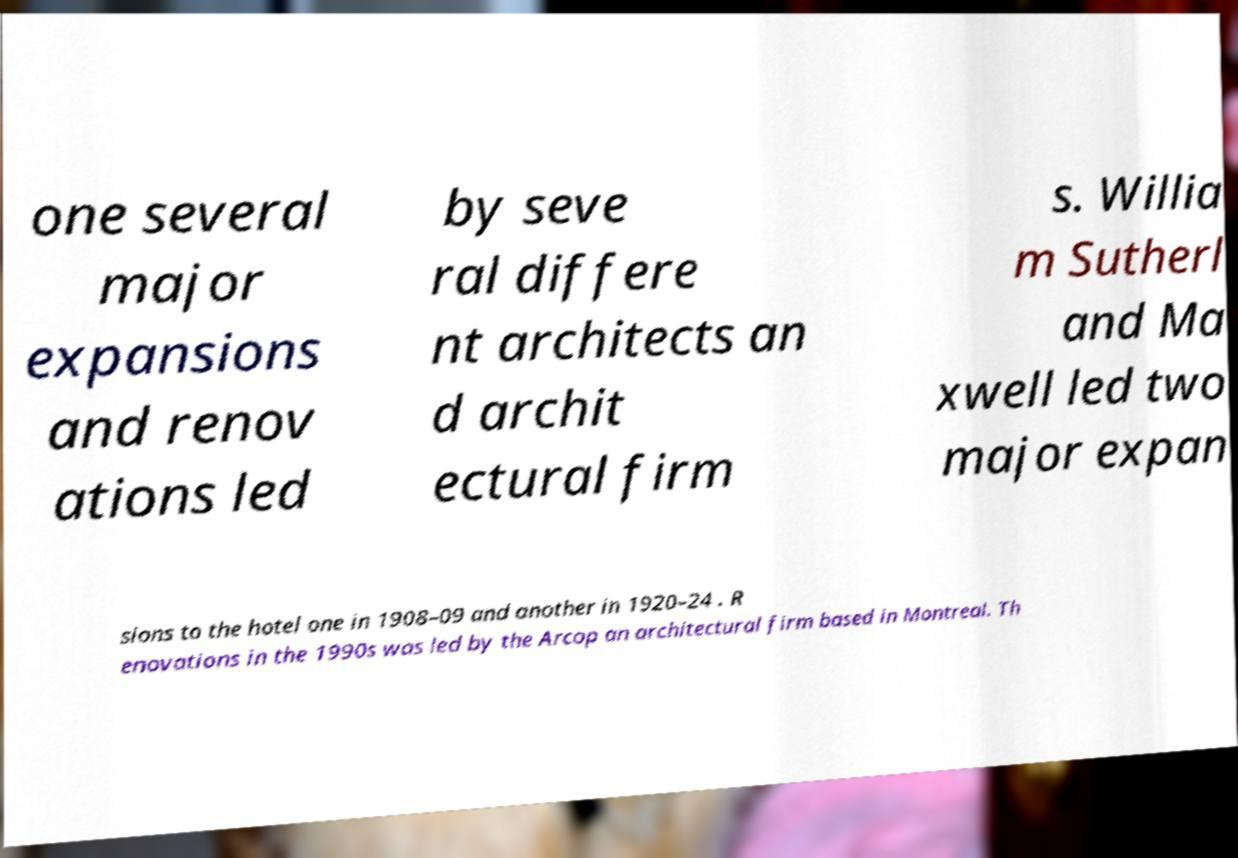I need the written content from this picture converted into text. Can you do that? one several major expansions and renov ations led by seve ral differe nt architects an d archit ectural firm s. Willia m Sutherl and Ma xwell led two major expan sions to the hotel one in 1908–09 and another in 1920–24 . R enovations in the 1990s was led by the Arcop an architectural firm based in Montreal. Th 